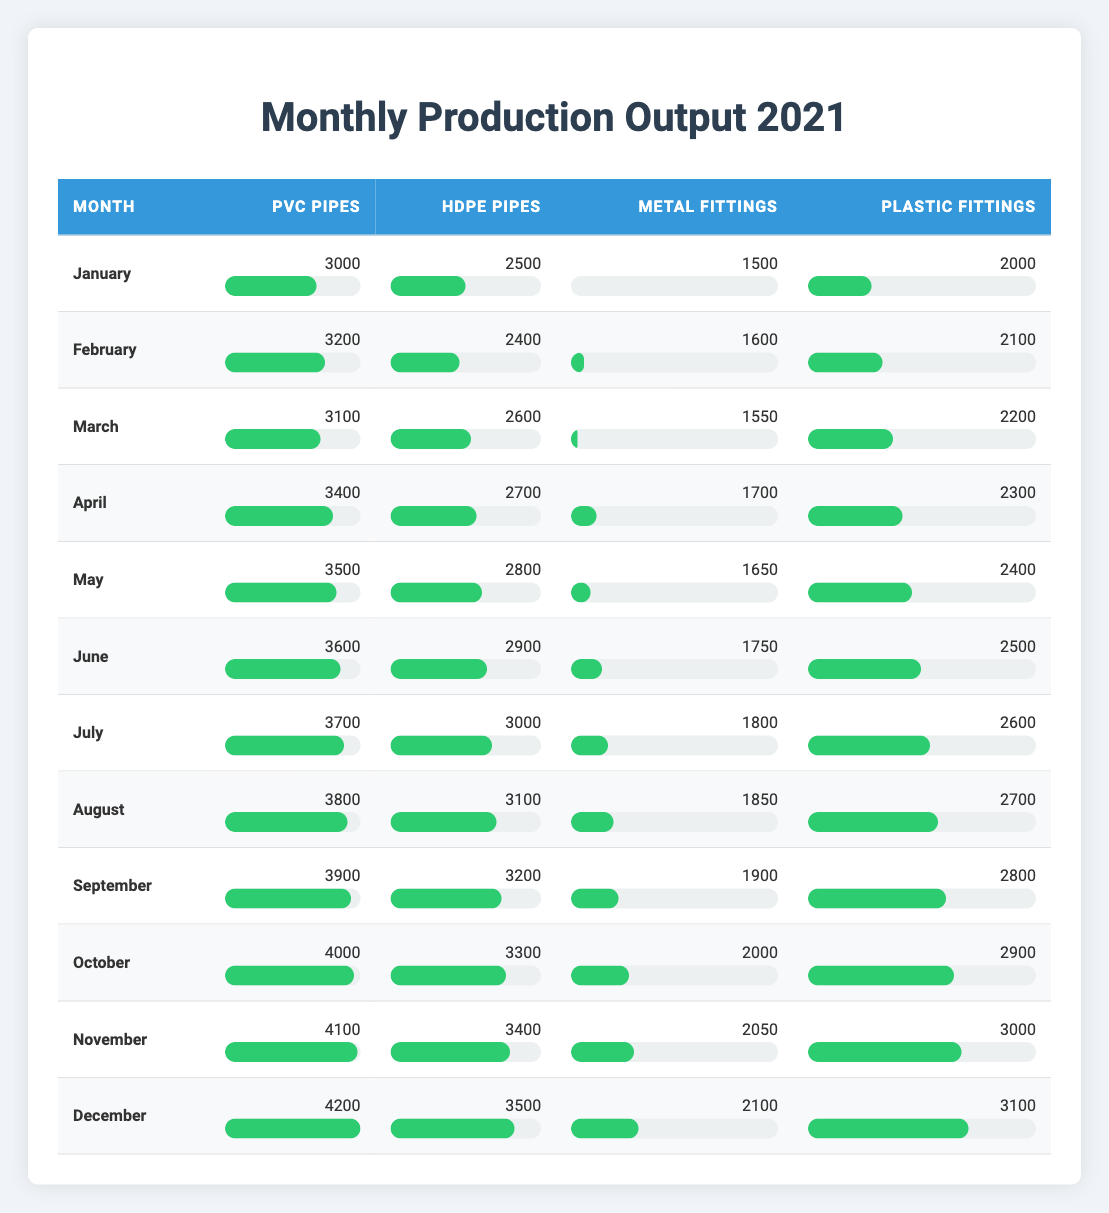What is the production output of PVC pipes in July? The table shows that the production output of PVC pipes in July is 3700.
Answer: 3700 Which month had the highest production of plastic fittings? By examining the table, December has the highest production of plastic fittings at 3100.
Answer: 3100 What is the total production of metal fittings from January to March? The production outputs for metal fittings are 1500 in January, 1600 in February, and 1550 in March. Adding these values gives 1500 + 1600 + 1550 = 4650.
Answer: 4650 Did the production of HDPE pipes increase every month? Observing the table, we see that the production of HDPE pipes was 2500 in January, 2400 in February, but increased to 2600 in March. This shows that it did not increase in February.
Answer: No What is the average production of PVC pipes over the entire year? The production outputs for PVC pipes from January to December are 3000, 3200, 3100, 3400, 3500, 3600, 3700, 3800, 3900, 4000, 4100, and 4200. Adding these values results in a total of 41,900. Dividing by 12 gives an average of 3491.67.
Answer: 3491.67 What is the difference in production between plastic fittings in December and February? From the table, the production of plastic fittings was 3100 in December and 2100 in February. The difference is calculated as 3100 - 2100 = 1000.
Answer: 1000 Which month had lower production of HDPE pipes, March or April? The table shows that March had a production of 2600 and April had 2700 for HDPE pipes. Therefore, March had lower production.
Answer: March What is the cumulative production of all pipes and fittings in October? In October, the production values are: PVC pipes = 4000, HDPE pipes = 3300, metal fittings = 2000, and plastic fittings = 2900. Summing these values gives 4000 + 3300 + 2000 + 2900 = 12200.
Answer: 12200 